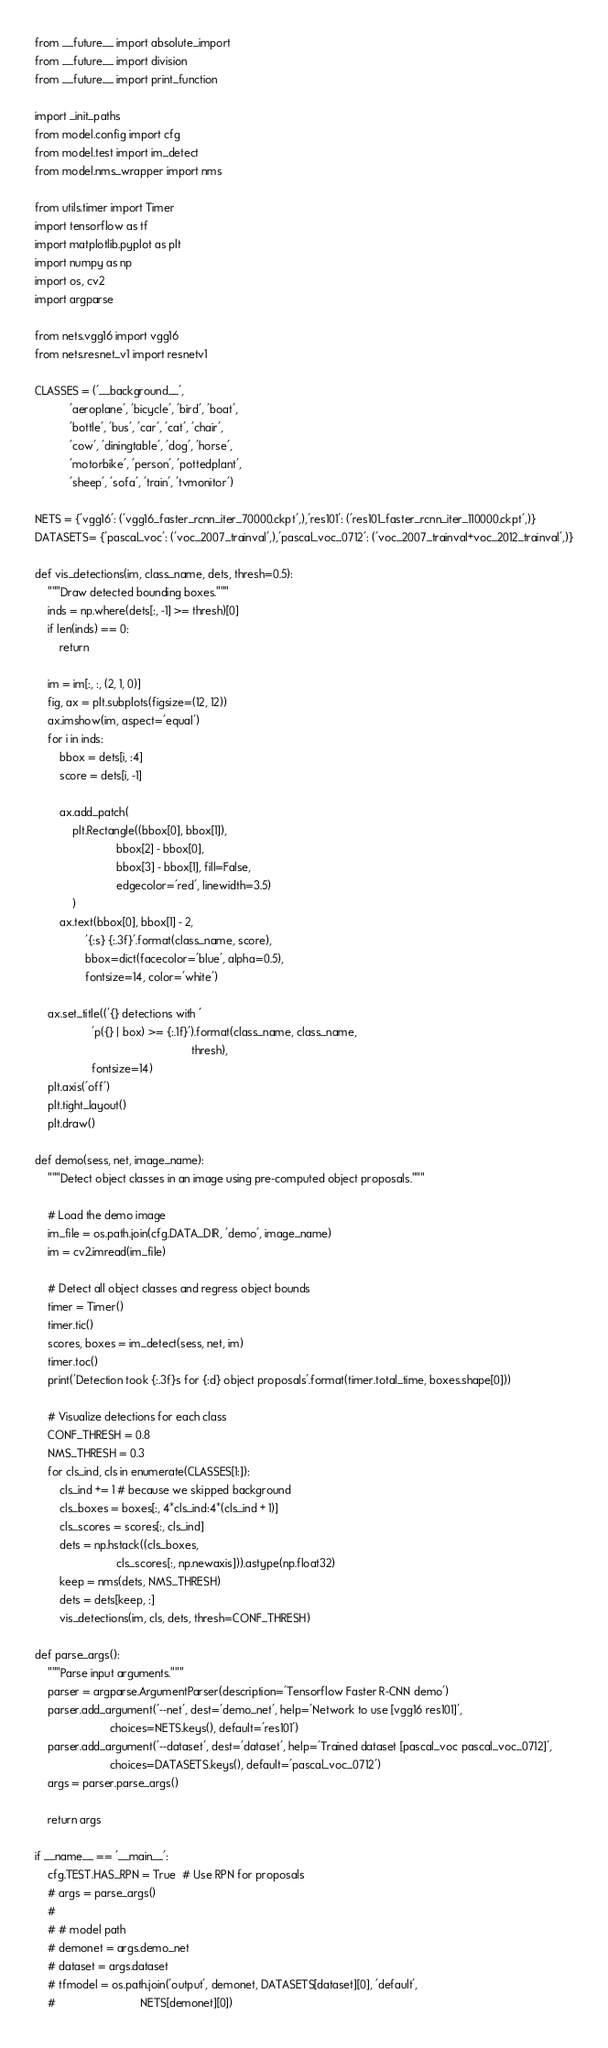Convert code to text. <code><loc_0><loc_0><loc_500><loc_500><_Python_>from __future__ import absolute_import
from __future__ import division
from __future__ import print_function

import _init_paths
from model.config import cfg
from model.test import im_detect
from model.nms_wrapper import nms

from utils.timer import Timer
import tensorflow as tf
import matplotlib.pyplot as plt
import numpy as np
import os, cv2
import argparse

from nets.vgg16 import vgg16
from nets.resnet_v1 import resnetv1

CLASSES = ('__background__',
           'aeroplane', 'bicycle', 'bird', 'boat',
           'bottle', 'bus', 'car', 'cat', 'chair',
           'cow', 'diningtable', 'dog', 'horse',
           'motorbike', 'person', 'pottedplant',
           'sheep', 'sofa', 'train', 'tvmonitor')

NETS = {'vgg16': ('vgg16_faster_rcnn_iter_70000.ckpt',),'res101': ('res101_faster_rcnn_iter_110000.ckpt',)}
DATASETS= {'pascal_voc': ('voc_2007_trainval',),'pascal_voc_0712': ('voc_2007_trainval+voc_2012_trainval',)}

def vis_detections(im, class_name, dets, thresh=0.5):
    """Draw detected bounding boxes."""
    inds = np.where(dets[:, -1] >= thresh)[0]
    if len(inds) == 0:
        return

    im = im[:, :, (2, 1, 0)]
    fig, ax = plt.subplots(figsize=(12, 12))
    ax.imshow(im, aspect='equal')
    for i in inds:
        bbox = dets[i, :4]
        score = dets[i, -1]

        ax.add_patch(
            plt.Rectangle((bbox[0], bbox[1]),
                          bbox[2] - bbox[0],
                          bbox[3] - bbox[1], fill=False,
                          edgecolor='red', linewidth=3.5)
            )
        ax.text(bbox[0], bbox[1] - 2,
                '{:s} {:.3f}'.format(class_name, score),
                bbox=dict(facecolor='blue', alpha=0.5),
                fontsize=14, color='white')

    ax.set_title(('{} detections with '
                  'p({} | box) >= {:.1f}').format(class_name, class_name,
                                                  thresh),
                  fontsize=14)
    plt.axis('off')
    plt.tight_layout()
    plt.draw()

def demo(sess, net, image_name):
    """Detect object classes in an image using pre-computed object proposals."""

    # Load the demo image
    im_file = os.path.join(cfg.DATA_DIR, 'demo', image_name)
    im = cv2.imread(im_file)

    # Detect all object classes and regress object bounds
    timer = Timer()
    timer.tic()
    scores, boxes = im_detect(sess, net, im)
    timer.toc()
    print('Detection took {:.3f}s for {:d} object proposals'.format(timer.total_time, boxes.shape[0]))

    # Visualize detections for each class
    CONF_THRESH = 0.8
    NMS_THRESH = 0.3
    for cls_ind, cls in enumerate(CLASSES[1:]):
        cls_ind += 1 # because we skipped background
        cls_boxes = boxes[:, 4*cls_ind:4*(cls_ind + 1)]
        cls_scores = scores[:, cls_ind]
        dets = np.hstack((cls_boxes,
                          cls_scores[:, np.newaxis])).astype(np.float32)
        keep = nms(dets, NMS_THRESH)
        dets = dets[keep, :]
        vis_detections(im, cls, dets, thresh=CONF_THRESH)

def parse_args():
    """Parse input arguments."""
    parser = argparse.ArgumentParser(description='Tensorflow Faster R-CNN demo')
    parser.add_argument('--net', dest='demo_net', help='Network to use [vgg16 res101]',
                        choices=NETS.keys(), default='res101')
    parser.add_argument('--dataset', dest='dataset', help='Trained dataset [pascal_voc pascal_voc_0712]',
                        choices=DATASETS.keys(), default='pascal_voc_0712')
    args = parser.parse_args()

    return args

if __name__ == '__main__':
    cfg.TEST.HAS_RPN = True  # Use RPN for proposals
    # args = parse_args()
    #
    # # model path
    # demonet = args.demo_net
    # dataset = args.dataset
    # tfmodel = os.path.join('output', demonet, DATASETS[dataset][0], 'default',
    #                           NETS[demonet][0])</code> 